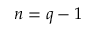Convert formula to latex. <formula><loc_0><loc_0><loc_500><loc_500>n = q - 1</formula> 